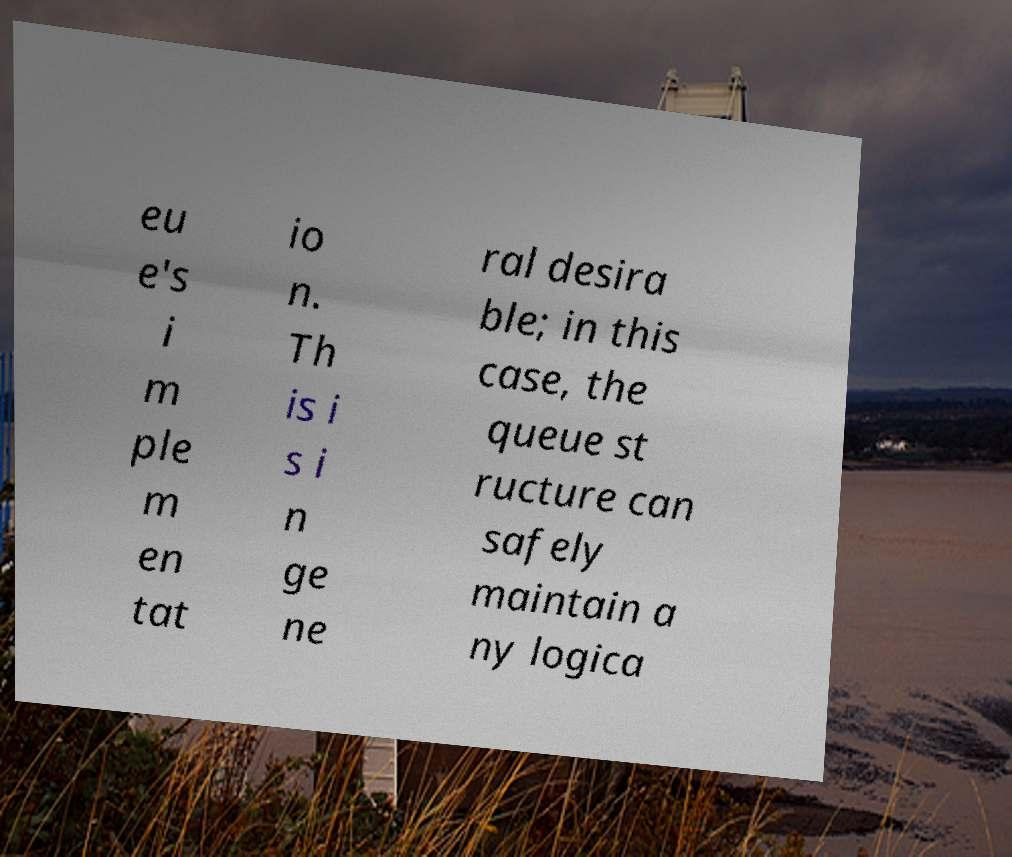Please identify and transcribe the text found in this image. eu e's i m ple m en tat io n. Th is i s i n ge ne ral desira ble; in this case, the queue st ructure can safely maintain a ny logica 